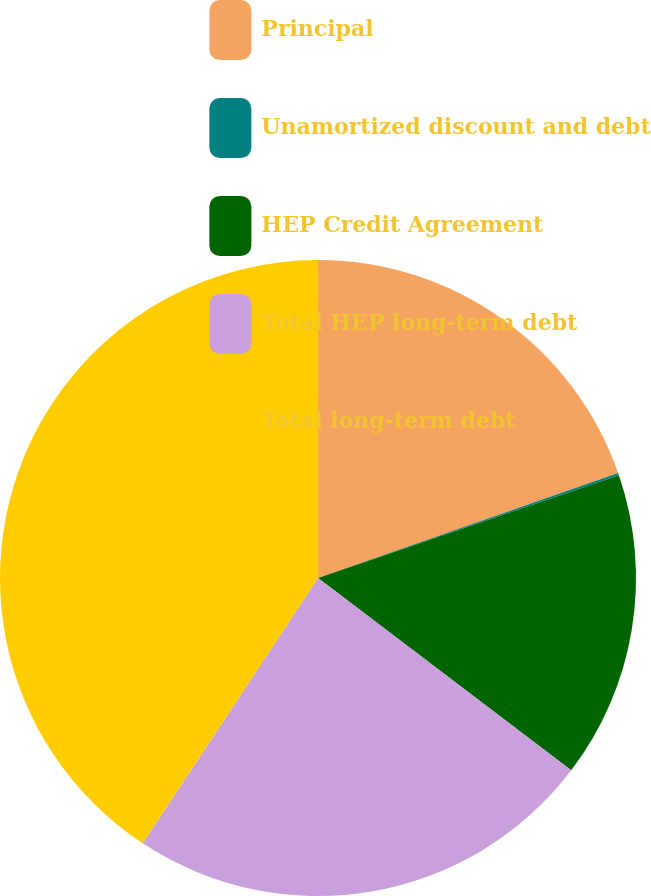<chart> <loc_0><loc_0><loc_500><loc_500><pie_chart><fcel>Principal<fcel>Unamortized discount and debt<fcel>HEP Credit Agreement<fcel>Total HEP long-term debt<fcel>Total long-term debt<nl><fcel>19.64%<fcel>0.12%<fcel>15.58%<fcel>23.95%<fcel>40.71%<nl></chart> 